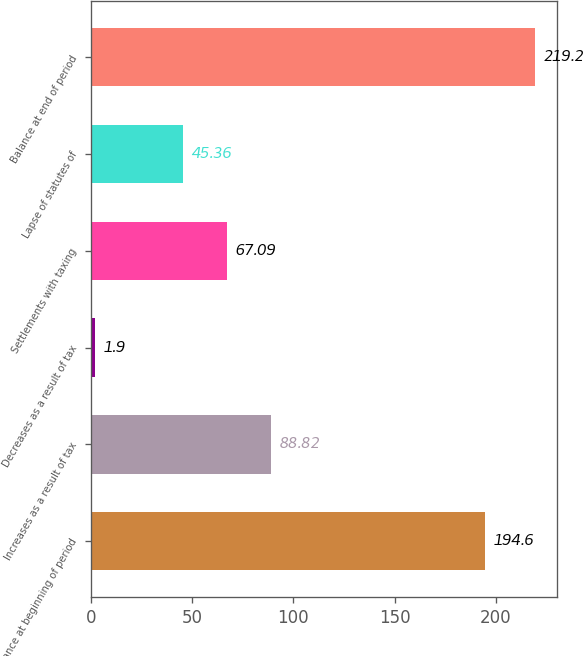Convert chart. <chart><loc_0><loc_0><loc_500><loc_500><bar_chart><fcel>Balance at beginning of period<fcel>Increases as a result of tax<fcel>Decreases as a result of tax<fcel>Settlements with taxing<fcel>Lapse of statutes of<fcel>Balance at end of period<nl><fcel>194.6<fcel>88.82<fcel>1.9<fcel>67.09<fcel>45.36<fcel>219.2<nl></chart> 